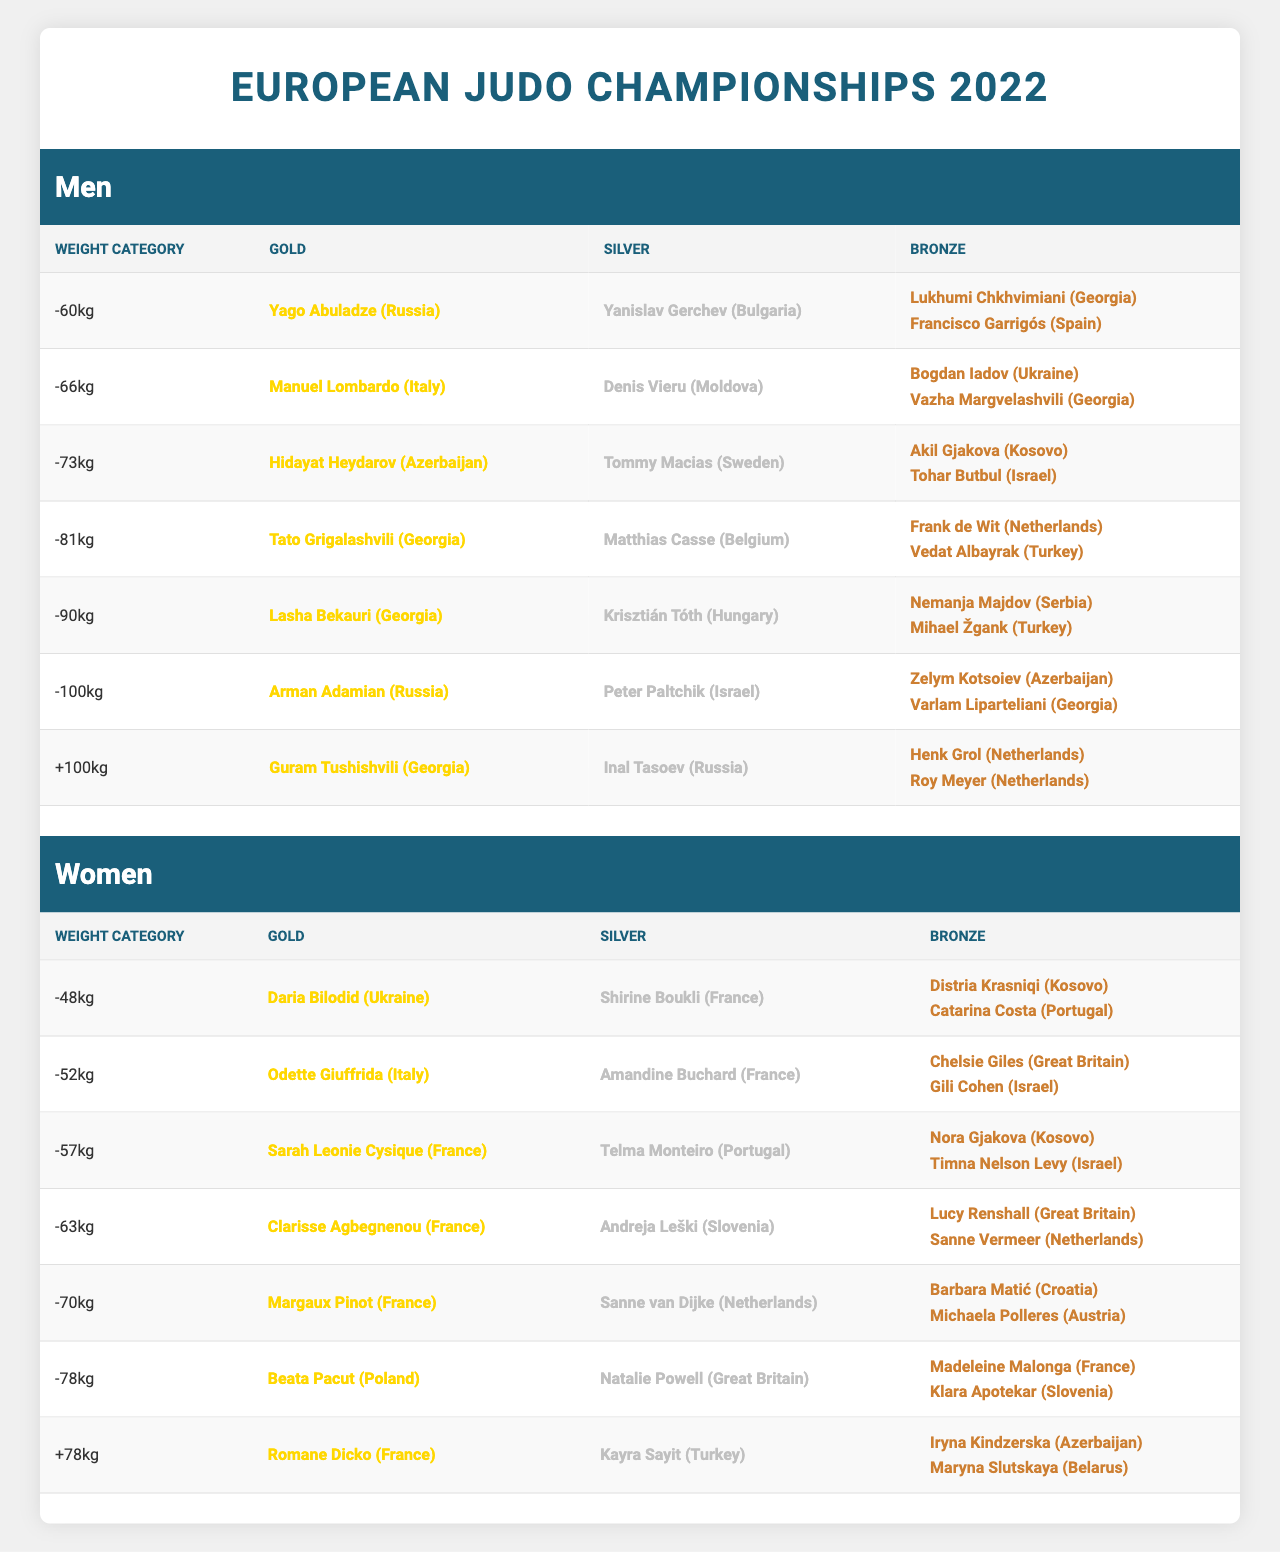What was the gold medal winner in the -81kg men's category? The table shows that Tato Grigalashvili from Georgia won the gold medal in the -81kg men's category.
Answer: Tato Grigalashvili (Georgia) How many bronze medalists are there in the +100kg category? The table indicates there are two bronze medalists listed for the +100kg category: Henk Grol and Roy Meyer, both from the Netherlands.
Answer: 2 Which country won the most gold medals in women's categories? By inspecting the gold medal winners in the women’s categories, France has three gold medalists: Clarisse Agbegnenou, Margaux Pinot, and Romane Dicko, more than any other country.
Answer: France Who won the silver medal in the -57kg women's category? The table specifies that Telma Monteiro from Portugal won the silver medal in the -57kg women's category.
Answer: Telma Monteiro (Portugal) Is there a medalist from Spain in the men's category? The table confirms that Francisco Garrigós won a bronze medal for Spain in the -60kg men's category.
Answer: Yes Which gender had more total weight categories represented in the medal counts? There are a total of 7 weight categories for women and 7 for men, making them equal in representation.
Answer: Equal What is the total number of bronze medals awarded in the women's categories? Each of the 7 women’s weight categories has 2 bronze medals awarded, so calculating gives 7 x 2 = 14; thus, 14 bronze medals were awarded in women’s categories.
Answer: 14 Which two countries represented in men's judo won silver medals? The table shows that Moldova and Israel won silver medals in men's categories; Denis Vieru represented Moldova in the -66kg and Peter Paltchik represented Israel in the -100kg.
Answer: Moldova and Israel What is the gold medal winner in the -48kg weight category? According to the table, Daria Bilodid from Ukraine won the gold medal in the -48kg women's category.
Answer: Daria Bilodid (Ukraine) How many athletes from Georgia won medals in the men's categories? In the men's categories, Georgia has 5 medalists: Yago Abuladze (-60kg), Hidayat Heydarov (-73kg), Tato Grigalashvili (-81kg), Lasha Bekauri (-90kg), and Guram Tushishvili (+100kg). This makes a total of 5.
Answer: 5 Which weight category had the highest representation by a single country for gold medals? The -100kg men's category had 2 medalists from Israel, with Peter Paltchik winning silver, indicating a strong performance from Israel, making it notable even though there may not be direct "gold" mention; hence, it's about overall presence.
Answer: -100kg men's category by Israel 